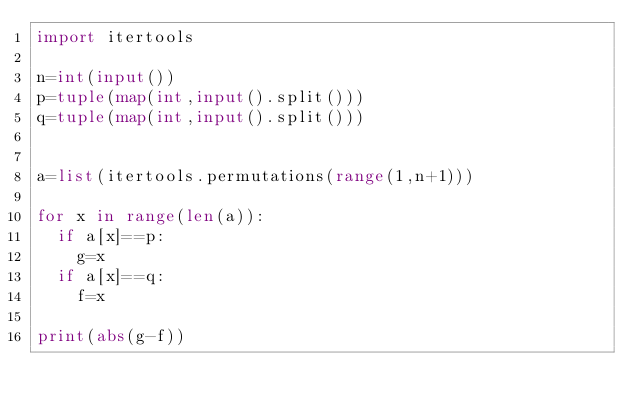<code> <loc_0><loc_0><loc_500><loc_500><_Python_>import itertools

n=int(input())
p=tuple(map(int,input().split()))
q=tuple(map(int,input().split()))


a=list(itertools.permutations(range(1,n+1)))

for x in range(len(a)):
  if a[x]==p:
    g=x
  if a[x]==q:
    f=x

print(abs(g-f))</code> 